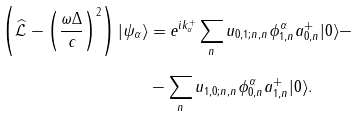Convert formula to latex. <formula><loc_0><loc_0><loc_500><loc_500>\left ( \widehat { \mathcal { L } } - \left ( \frac { \omega \Delta } { c } \right ) ^ { 2 } \right ) | \psi _ { \alpha } \rangle & = e ^ { i k _ { \alpha } ^ { + } } \sum _ { n } u _ { 0 , 1 ; n , n } \phi _ { 1 , n } ^ { \alpha } a _ { 0 , n } ^ { + } | 0 \rangle - \\ & - \sum _ { n } u _ { 1 , 0 ; n , n } \phi _ { 0 , n } ^ { \alpha } a _ { 1 , n } ^ { + } | 0 \rangle .</formula> 